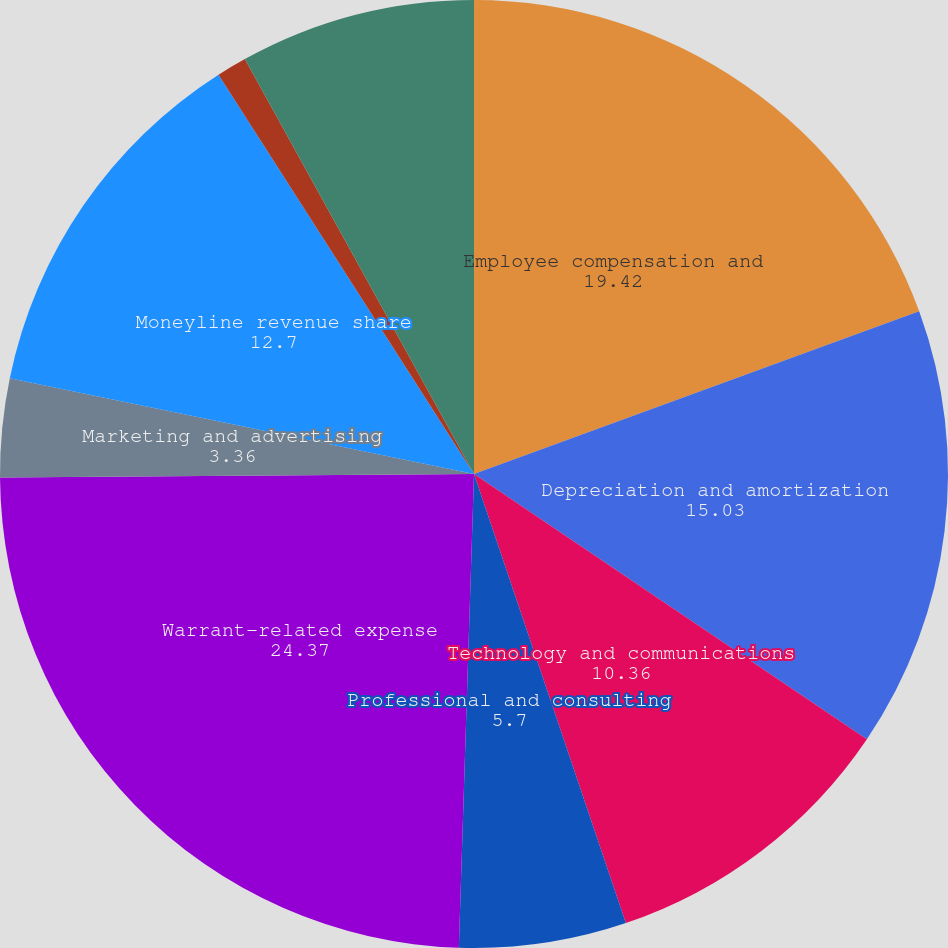Convert chart. <chart><loc_0><loc_0><loc_500><loc_500><pie_chart><fcel>Employee compensation and<fcel>Depreciation and amortization<fcel>Technology and communications<fcel>Professional and consulting<fcel>Warrant-related expense<fcel>Marketing and advertising<fcel>Moneyline revenue share<fcel>General and administrative<fcel>Total expenses<nl><fcel>19.42%<fcel>15.03%<fcel>10.36%<fcel>5.7%<fcel>24.37%<fcel>3.36%<fcel>12.7%<fcel>1.03%<fcel>8.03%<nl></chart> 